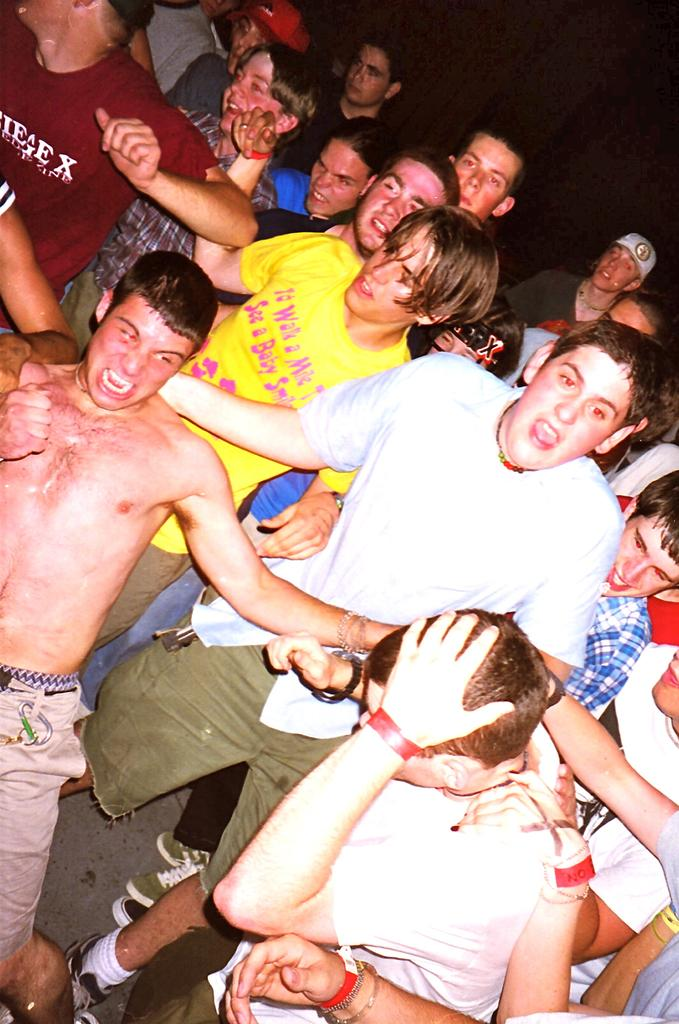Who is present in the image? There are people in the image. What are the people doing in the image? The people are standing and dancing in the image. Where is the dancing taking place? The dancing is taking place on a floor. What type of cactus can be seen in the background of the image? There is no cactus present in the image; it features people dancing on a floor. What scent is associated with the dancing in the image? There is no mention of a scent in the image, as it focuses on the people dancing on a floor. 